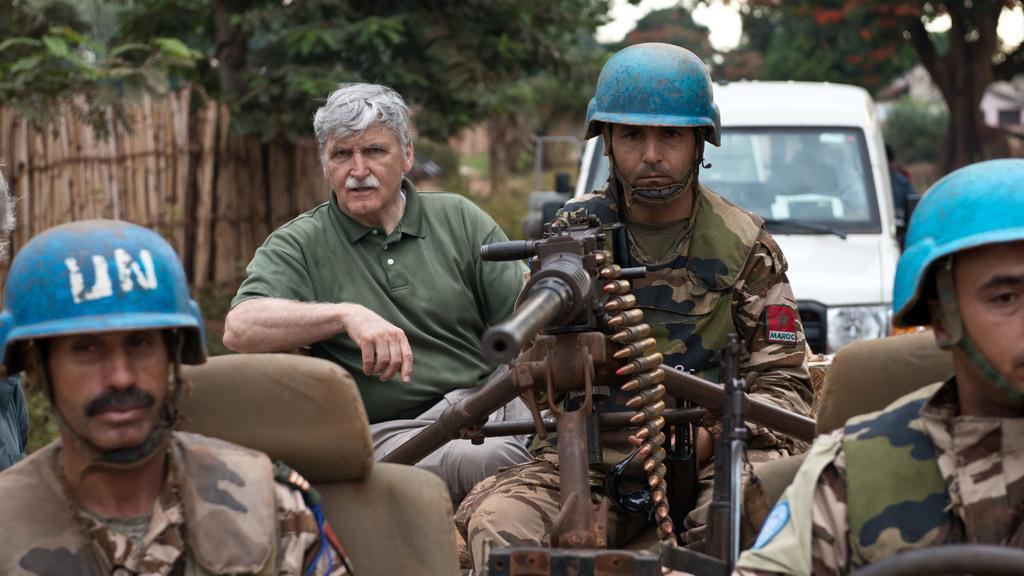How would you summarize this image in a sentence or two? In this we can describe about the military soldier wearing blue color helmet sitting with machine gun in the jeep. Beside there is a man wearing green color t-shirt sitting and looking into the camera. In the background we can see a bamboo wall and some trees. 